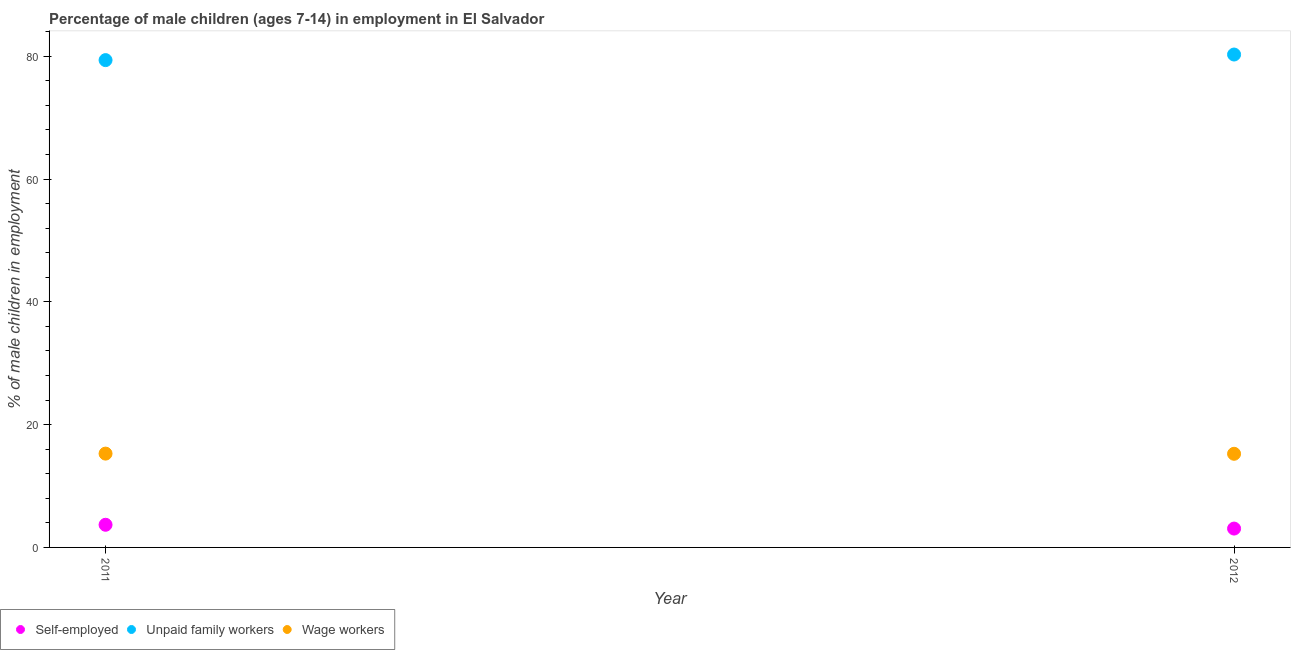How many different coloured dotlines are there?
Keep it short and to the point. 3. Is the number of dotlines equal to the number of legend labels?
Your response must be concise. Yes. What is the percentage of children employed as wage workers in 2011?
Your answer should be compact. 15.28. Across all years, what is the maximum percentage of self employed children?
Offer a terse response. 3.69. Across all years, what is the minimum percentage of children employed as unpaid family workers?
Provide a short and direct response. 79.37. What is the total percentage of self employed children in the graph?
Your answer should be compact. 6.76. What is the difference between the percentage of children employed as unpaid family workers in 2011 and that in 2012?
Your answer should be very brief. -0.91. What is the difference between the percentage of children employed as wage workers in 2011 and the percentage of children employed as unpaid family workers in 2012?
Offer a very short reply. -65. What is the average percentage of children employed as unpaid family workers per year?
Your response must be concise. 79.83. In the year 2011, what is the difference between the percentage of children employed as unpaid family workers and percentage of self employed children?
Keep it short and to the point. 75.68. In how many years, is the percentage of self employed children greater than 4 %?
Ensure brevity in your answer.  0. What is the ratio of the percentage of children employed as wage workers in 2011 to that in 2012?
Provide a succinct answer. 1. Is the percentage of children employed as wage workers in 2011 less than that in 2012?
Your response must be concise. No. Is the percentage of self employed children strictly greater than the percentage of children employed as unpaid family workers over the years?
Give a very brief answer. No. How many dotlines are there?
Offer a very short reply. 3. How many years are there in the graph?
Provide a succinct answer. 2. What is the difference between two consecutive major ticks on the Y-axis?
Give a very brief answer. 20. Does the graph contain any zero values?
Ensure brevity in your answer.  No. Where does the legend appear in the graph?
Offer a terse response. Bottom left. How many legend labels are there?
Ensure brevity in your answer.  3. How are the legend labels stacked?
Make the answer very short. Horizontal. What is the title of the graph?
Ensure brevity in your answer.  Percentage of male children (ages 7-14) in employment in El Salvador. Does "Taxes on international trade" appear as one of the legend labels in the graph?
Make the answer very short. No. What is the label or title of the Y-axis?
Give a very brief answer. % of male children in employment. What is the % of male children in employment in Self-employed in 2011?
Your response must be concise. 3.69. What is the % of male children in employment of Unpaid family workers in 2011?
Offer a very short reply. 79.37. What is the % of male children in employment in Wage workers in 2011?
Provide a succinct answer. 15.28. What is the % of male children in employment of Self-employed in 2012?
Offer a very short reply. 3.07. What is the % of male children in employment in Unpaid family workers in 2012?
Your answer should be very brief. 80.28. What is the % of male children in employment of Wage workers in 2012?
Give a very brief answer. 15.25. Across all years, what is the maximum % of male children in employment in Self-employed?
Your answer should be very brief. 3.69. Across all years, what is the maximum % of male children in employment of Unpaid family workers?
Your answer should be very brief. 80.28. Across all years, what is the maximum % of male children in employment of Wage workers?
Give a very brief answer. 15.28. Across all years, what is the minimum % of male children in employment of Self-employed?
Offer a very short reply. 3.07. Across all years, what is the minimum % of male children in employment in Unpaid family workers?
Provide a succinct answer. 79.37. Across all years, what is the minimum % of male children in employment of Wage workers?
Your answer should be compact. 15.25. What is the total % of male children in employment of Self-employed in the graph?
Your answer should be very brief. 6.76. What is the total % of male children in employment in Unpaid family workers in the graph?
Make the answer very short. 159.65. What is the total % of male children in employment of Wage workers in the graph?
Provide a short and direct response. 30.53. What is the difference between the % of male children in employment of Self-employed in 2011 and that in 2012?
Offer a very short reply. 0.62. What is the difference between the % of male children in employment of Unpaid family workers in 2011 and that in 2012?
Your response must be concise. -0.91. What is the difference between the % of male children in employment of Self-employed in 2011 and the % of male children in employment of Unpaid family workers in 2012?
Give a very brief answer. -76.59. What is the difference between the % of male children in employment of Self-employed in 2011 and the % of male children in employment of Wage workers in 2012?
Make the answer very short. -11.56. What is the difference between the % of male children in employment of Unpaid family workers in 2011 and the % of male children in employment of Wage workers in 2012?
Offer a very short reply. 64.12. What is the average % of male children in employment in Self-employed per year?
Provide a succinct answer. 3.38. What is the average % of male children in employment of Unpaid family workers per year?
Offer a very short reply. 79.83. What is the average % of male children in employment in Wage workers per year?
Provide a short and direct response. 15.27. In the year 2011, what is the difference between the % of male children in employment in Self-employed and % of male children in employment in Unpaid family workers?
Your answer should be compact. -75.68. In the year 2011, what is the difference between the % of male children in employment in Self-employed and % of male children in employment in Wage workers?
Your answer should be compact. -11.59. In the year 2011, what is the difference between the % of male children in employment in Unpaid family workers and % of male children in employment in Wage workers?
Ensure brevity in your answer.  64.09. In the year 2012, what is the difference between the % of male children in employment of Self-employed and % of male children in employment of Unpaid family workers?
Make the answer very short. -77.21. In the year 2012, what is the difference between the % of male children in employment in Self-employed and % of male children in employment in Wage workers?
Your response must be concise. -12.18. In the year 2012, what is the difference between the % of male children in employment of Unpaid family workers and % of male children in employment of Wage workers?
Give a very brief answer. 65.03. What is the ratio of the % of male children in employment of Self-employed in 2011 to that in 2012?
Your answer should be very brief. 1.2. What is the ratio of the % of male children in employment in Unpaid family workers in 2011 to that in 2012?
Your response must be concise. 0.99. What is the difference between the highest and the second highest % of male children in employment of Self-employed?
Keep it short and to the point. 0.62. What is the difference between the highest and the second highest % of male children in employment of Unpaid family workers?
Your answer should be compact. 0.91. What is the difference between the highest and the lowest % of male children in employment of Self-employed?
Provide a short and direct response. 0.62. What is the difference between the highest and the lowest % of male children in employment in Unpaid family workers?
Give a very brief answer. 0.91. What is the difference between the highest and the lowest % of male children in employment of Wage workers?
Offer a terse response. 0.03. 